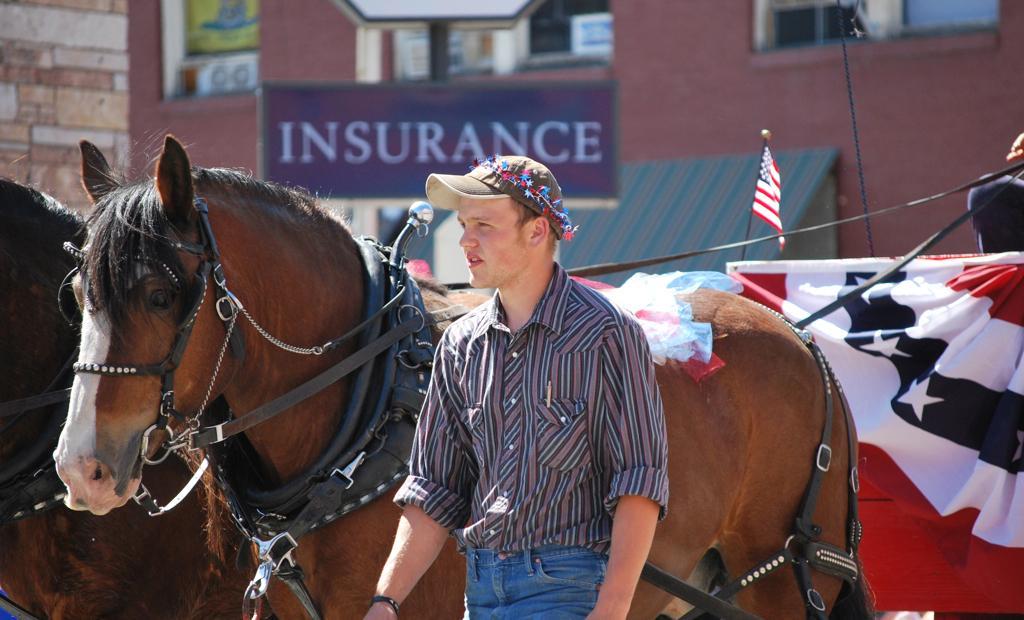Please provide a concise description of this image. There is a man here in the middle behind him there is a horse cart,hoarding,flag and a building. 